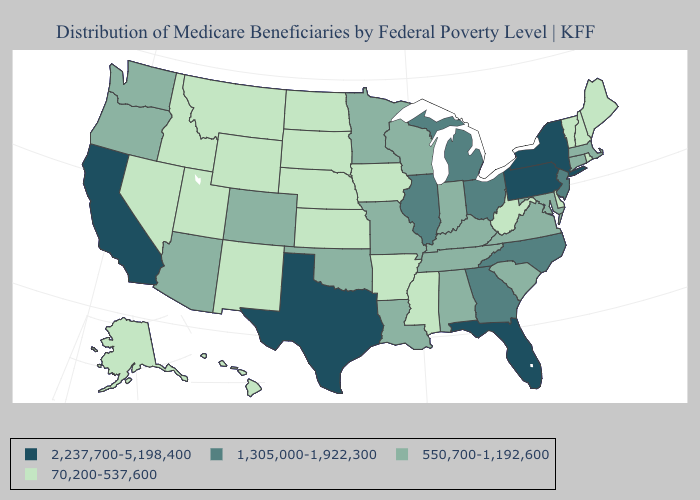What is the value of Utah?
Give a very brief answer. 70,200-537,600. Name the states that have a value in the range 1,305,000-1,922,300?
Quick response, please. Georgia, Illinois, Michigan, New Jersey, North Carolina, Ohio. Among the states that border Texas , does Oklahoma have the lowest value?
Answer briefly. No. Name the states that have a value in the range 2,237,700-5,198,400?
Be succinct. California, Florida, New York, Pennsylvania, Texas. What is the highest value in states that border Louisiana?
Short answer required. 2,237,700-5,198,400. Among the states that border Massachusetts , does New York have the lowest value?
Keep it brief. No. Does South Dakota have the lowest value in the USA?
Give a very brief answer. Yes. Among the states that border Wyoming , does Montana have the highest value?
Answer briefly. No. Does Rhode Island have a higher value than Wyoming?
Quick response, please. No. Among the states that border Washington , does Idaho have the lowest value?
Give a very brief answer. Yes. What is the value of Nebraska?
Be succinct. 70,200-537,600. What is the lowest value in the South?
Quick response, please. 70,200-537,600. Among the states that border Maine , which have the highest value?
Keep it brief. New Hampshire. Which states have the highest value in the USA?
Be succinct. California, Florida, New York, Pennsylvania, Texas. Which states have the lowest value in the Northeast?
Quick response, please. Maine, New Hampshire, Rhode Island, Vermont. 